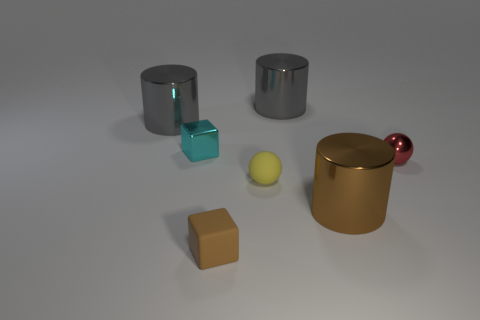Do the cyan object and the brown shiny cylinder have the same size?
Offer a very short reply. No. What material is the tiny brown object?
Keep it short and to the point. Rubber. There is a brown thing that is the same size as the red shiny sphere; what is it made of?
Make the answer very short. Rubber. Is there another cyan cube of the same size as the metallic block?
Keep it short and to the point. No. Is the number of red spheres that are in front of the big brown object the same as the number of tiny shiny blocks that are in front of the cyan block?
Provide a succinct answer. Yes. Are there more gray metallic cylinders than tiny objects?
Your response must be concise. No. What number of shiny objects are either small red things or cyan things?
Ensure brevity in your answer.  2. What number of rubber objects are the same color as the metal block?
Your answer should be compact. 0. What is the material of the sphere to the left of the large object that is behind the large thing on the left side of the tiny brown rubber object?
Ensure brevity in your answer.  Rubber. What is the color of the cylinder that is in front of the cylinder that is to the left of the small cyan metal thing?
Ensure brevity in your answer.  Brown. 